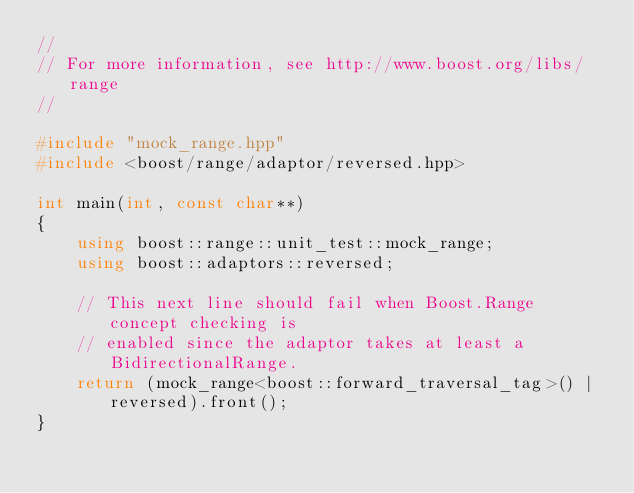<code> <loc_0><loc_0><loc_500><loc_500><_C++_>//
// For more information, see http://www.boost.org/libs/range
//

#include "mock_range.hpp"
#include <boost/range/adaptor/reversed.hpp>

int main(int, const char**)
{
    using boost::range::unit_test::mock_range;
    using boost::adaptors::reversed;

    // This next line should fail when Boost.Range concept checking is
    // enabled since the adaptor takes at least a BidirectionalRange.
    return (mock_range<boost::forward_traversal_tag>() | reversed).front();
}
 
</code> 